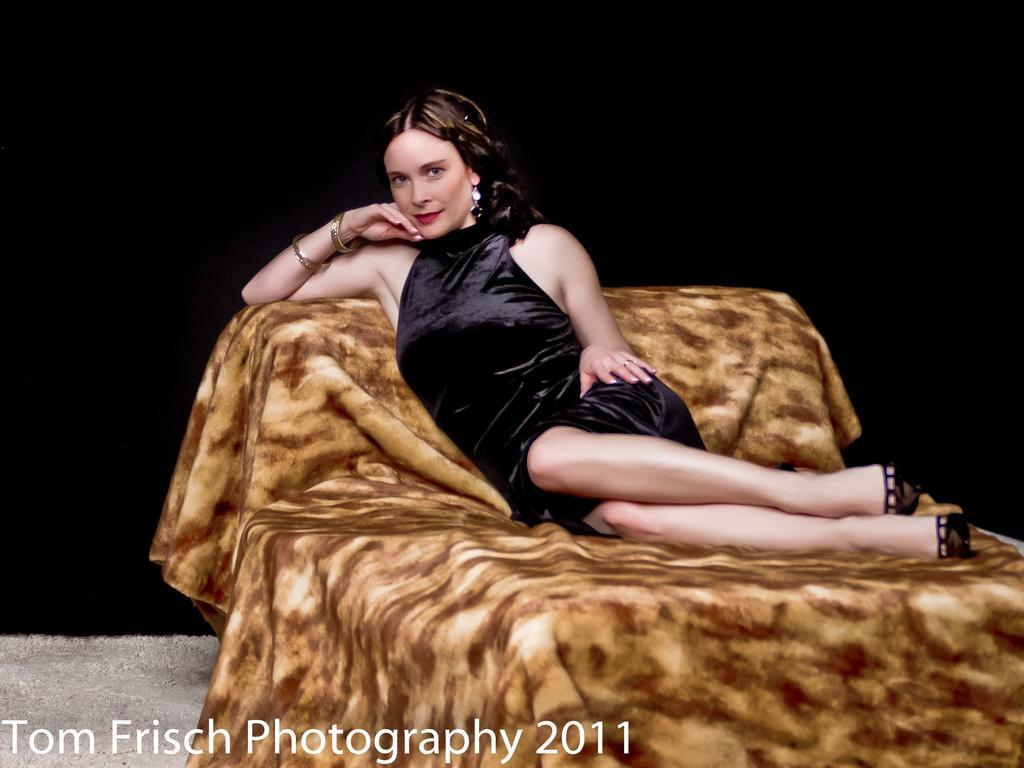How would you summarize this image in a sentence or two? In this picture we can see a woman sitting on a bed. There is a dark background. At the bottom we can see a watermark. 